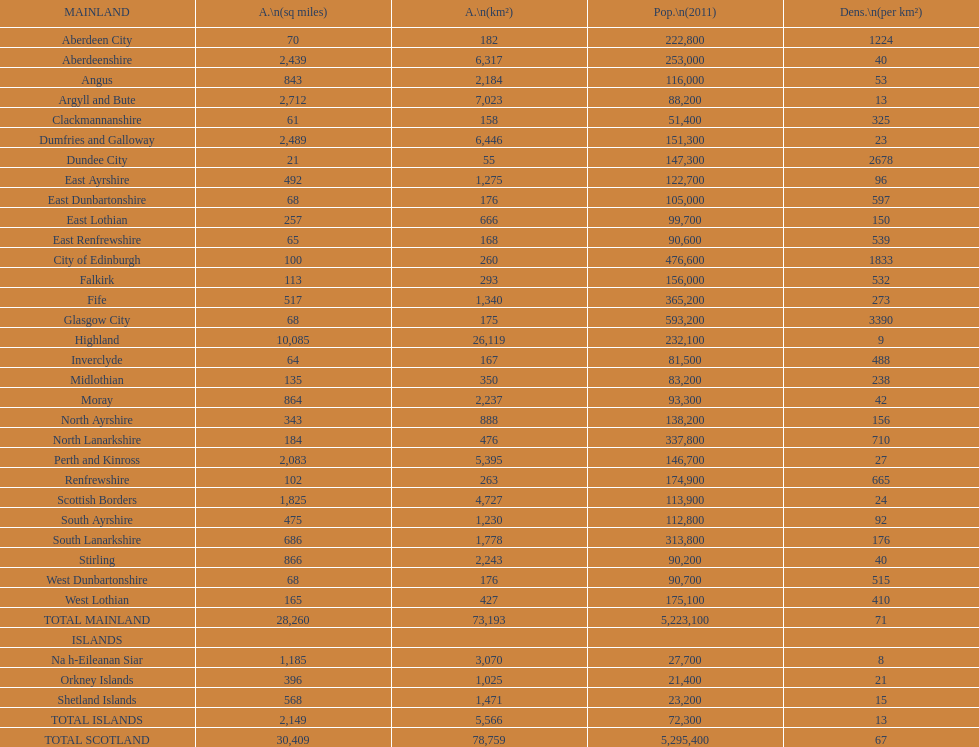What is the average population density in mainland cities? 71. 